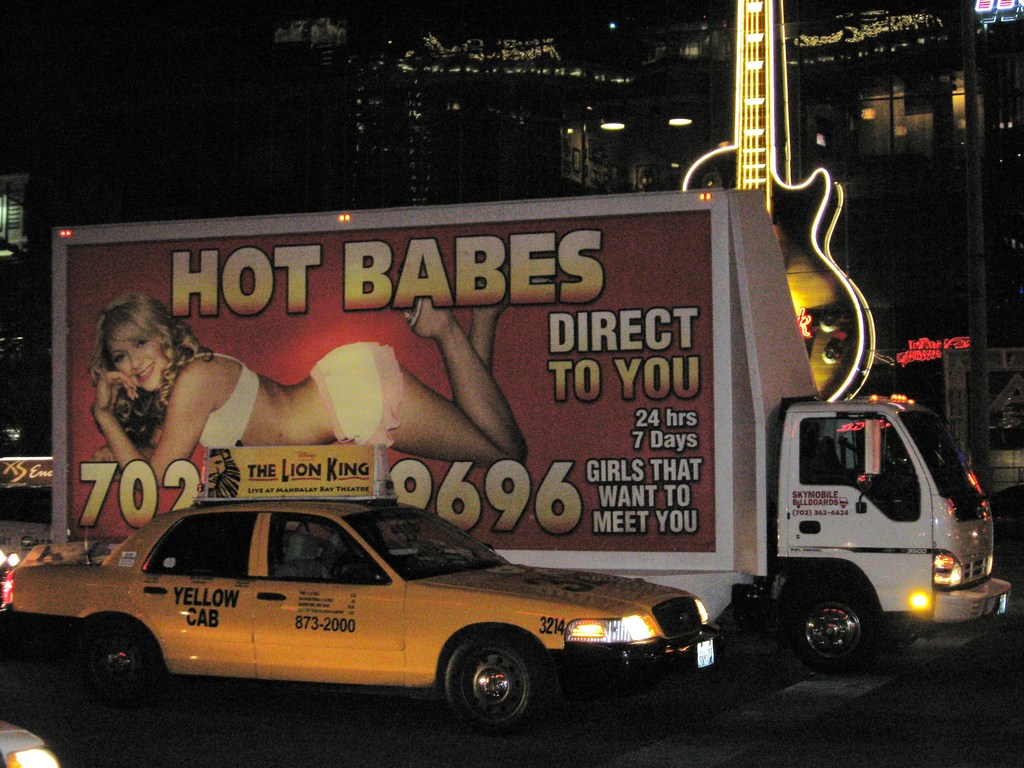How might the presence of such advertisements impact the perception of the city or area depicted? The presence of such bold and prominent advertisements can impact the city's perception in various ways. It could attract a specific demographic interested in vibrant nightlife and entertainment, potentially boosting local businesses and tourism. However, it might also spark controversy or debate about the appropriateness and aesthetics of public advertisements, influencing discussions about urban planning and community standards. 